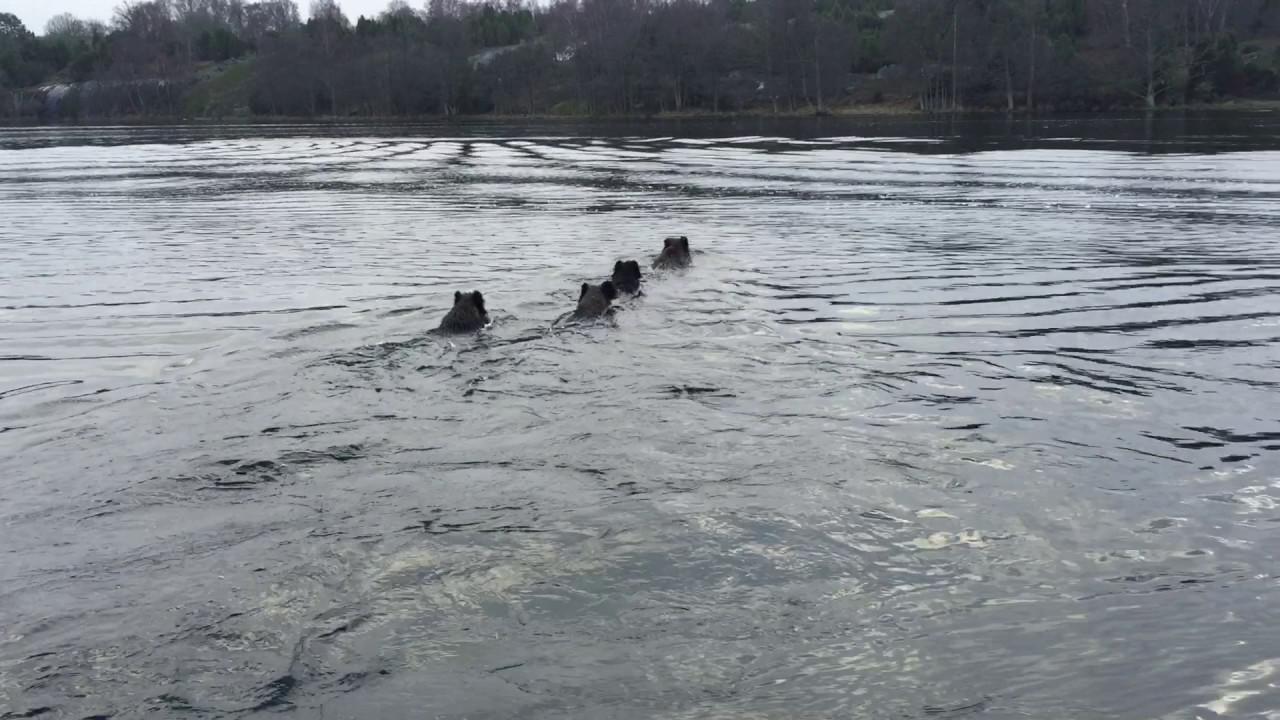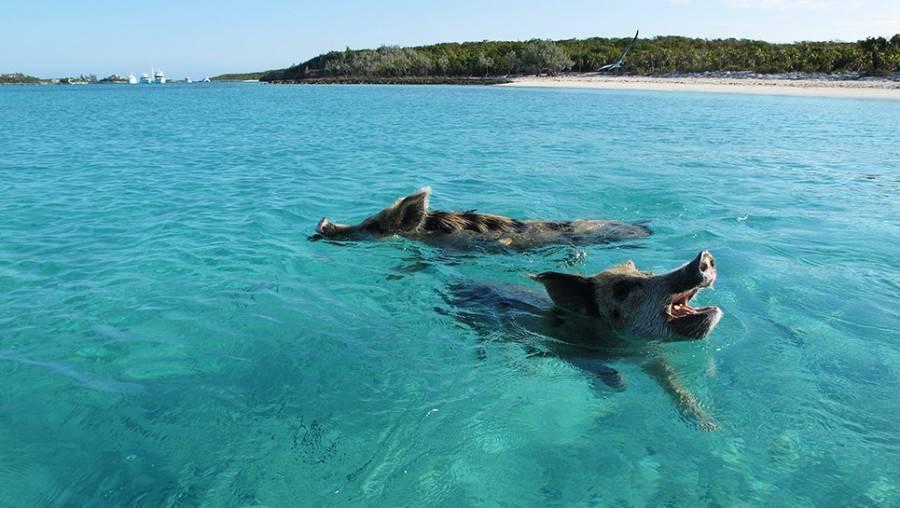The first image is the image on the left, the second image is the image on the right. For the images displayed, is the sentence "All of the hogs are in water and some of them are in crystal blue water." factually correct? Answer yes or no. Yes. The first image is the image on the left, the second image is the image on the right. Examine the images to the left and right. Is the description "Both images feature pigs in the water." accurate? Answer yes or no. Yes. 